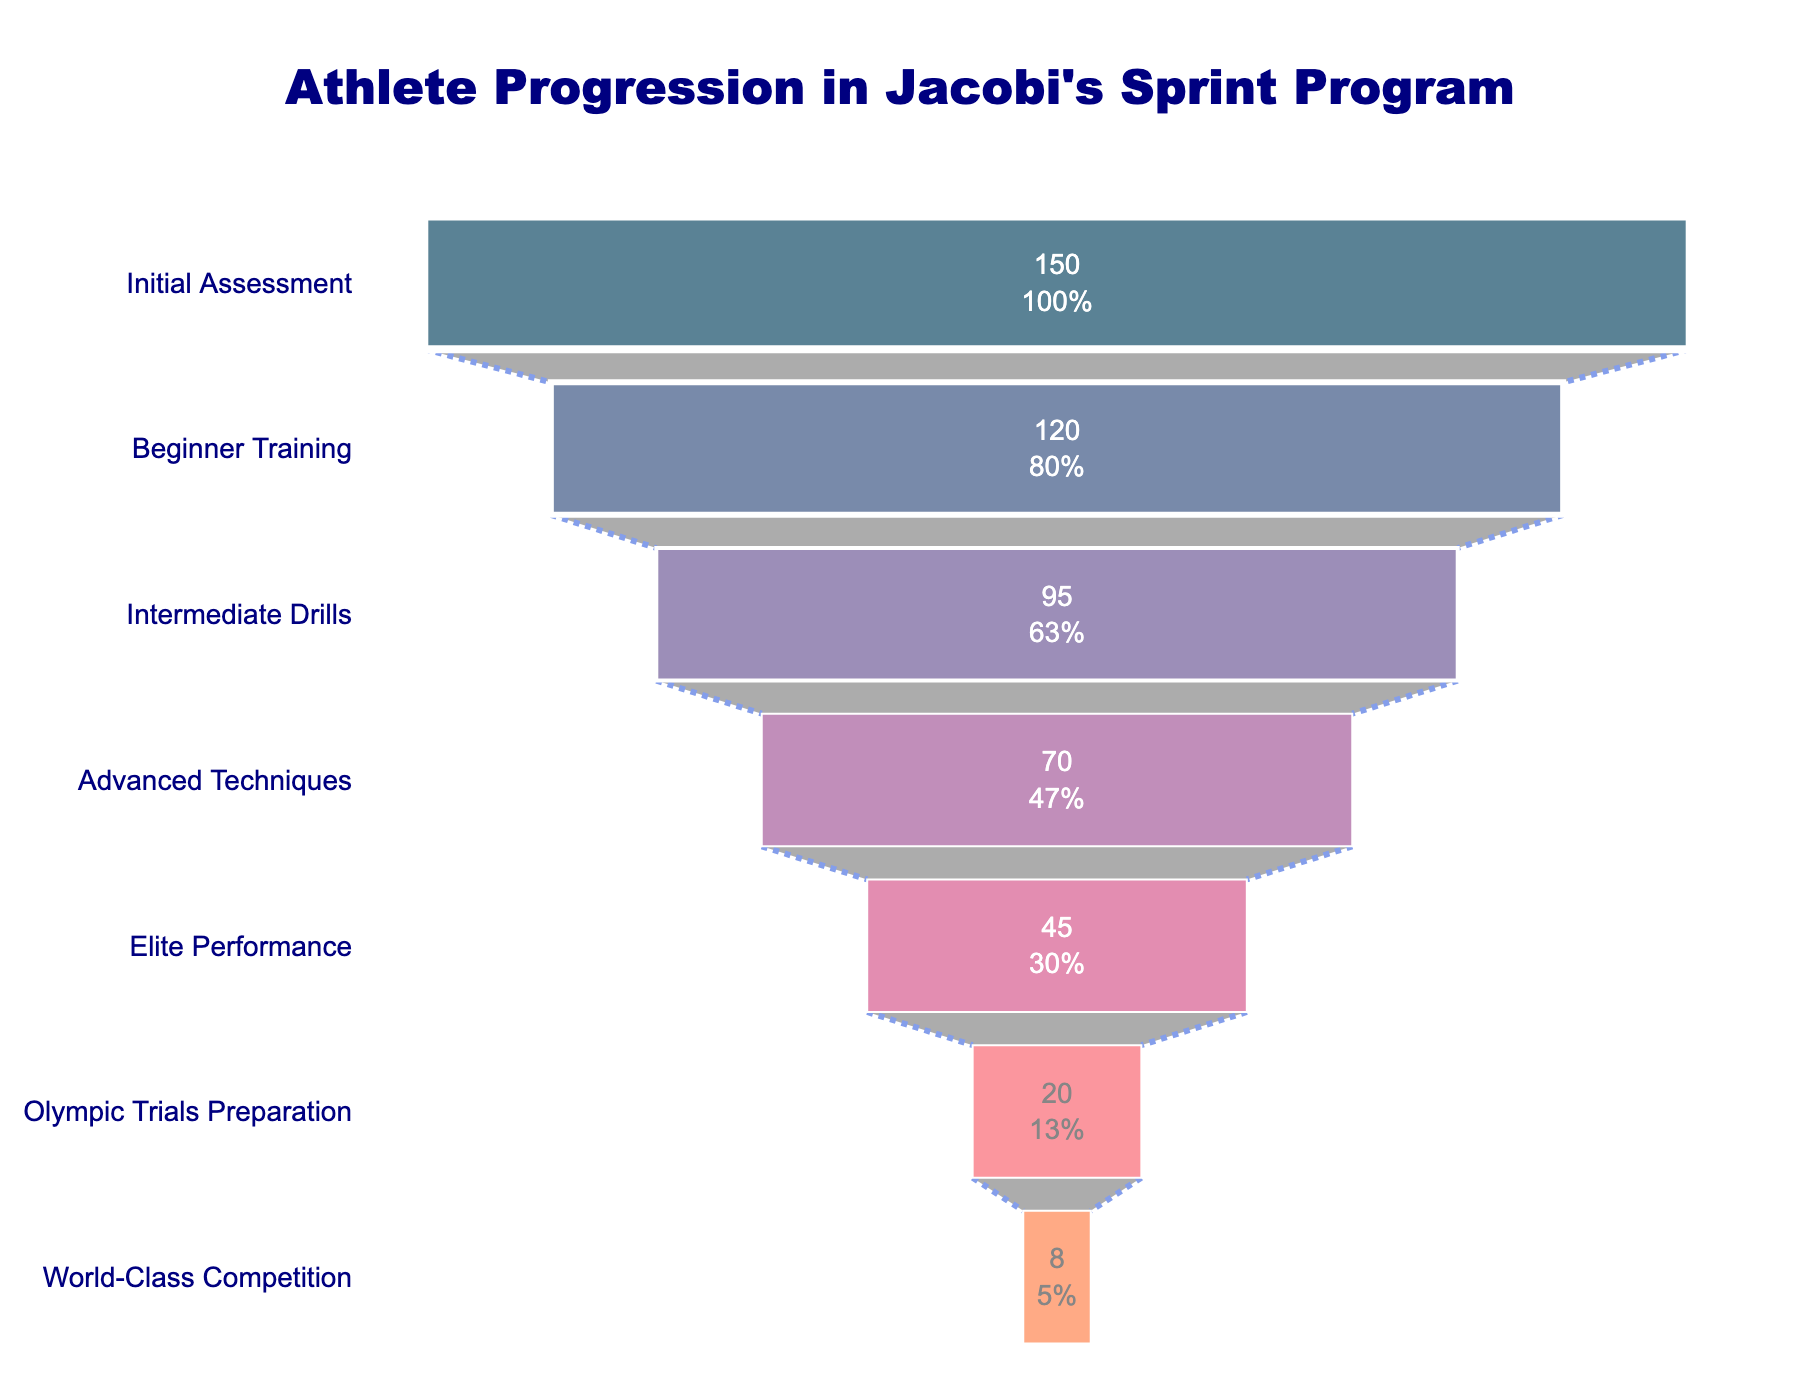What is the title of the chart? The title can be found at the top of the chart. It states the main focus of the visualized data.
Answer: Athlete Progression in Jacobi's Sprint Program How many stages are there in Jacobi's sprint program? Count the number of different stages listed on the vertical axis (y-axis) of the funnel chart.
Answer: 7 What percentage of athletes move from Initial Assessment to Beginner Training? The percentage is usually displayed within the funnel shape at the point corresponding to Beginner Training. Look for the text that indicates this percentage.
Answer: 80.0% Which stage has the fewest athletes? Look for the stage at the smallest, bottom part of the funnel chart. That represents the stage with the fewest athletes.
Answer: World-Class Competition How many athletes participate in the Advanced Techniques stage? Locate the stage labeled Advanced Techniques and read the number inside or next to it representing the count of athletes at that stage.
Answer: 70 What is the difference in the number of athletes between Intermediate Drills and Elite Performance? Subtract the number of athletes at Elite Performance from those at Intermediate Drills: 95 (Intermediate Drills) - 45 (Elite Performance).
Answer: 50 How many athletes progress from Olympic Trials Preparation to World-Class Competition? Look at the funnel sections corresponding to these stages; the number of athletes moving from the higher stage (Olympic Trials Preparation) to the lower stage (World-Class Competition) is found by comparing their values.
Answer: 12 Which stage sees the most significant drop in athlete numbers? Observe the differences in the number of athletes between consecutive stages. The largest drop indicates the stage where the most significant drop occurs.
Answer: Advanced Techniques to Elite Performance What percentage of the initial athletes reach the World-Class Competition stage? Identify the final stage (World-Class Competition) and find the percentage value showing the fraction of initial athletes who reached it, typically noted within that stage in the funnel chart.
Answer: 5.3% Of the athletes that start in the Beginner Training stage, what percentage reach the Intermediate Drills stage? Identify the values for Beginner Training and Intermediate Drills. Calculate the percentage by dividing the number of athletes in Intermediate Drills by those in Beginner Training: (95 / 120) * 100.
Answer: 79.2% 